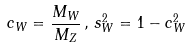<formula> <loc_0><loc_0><loc_500><loc_500>c _ { W } = \frac { M _ { W } } { M _ { Z } } \, , \, s ^ { 2 } _ { W } = 1 - c ^ { 2 } _ { W }</formula> 